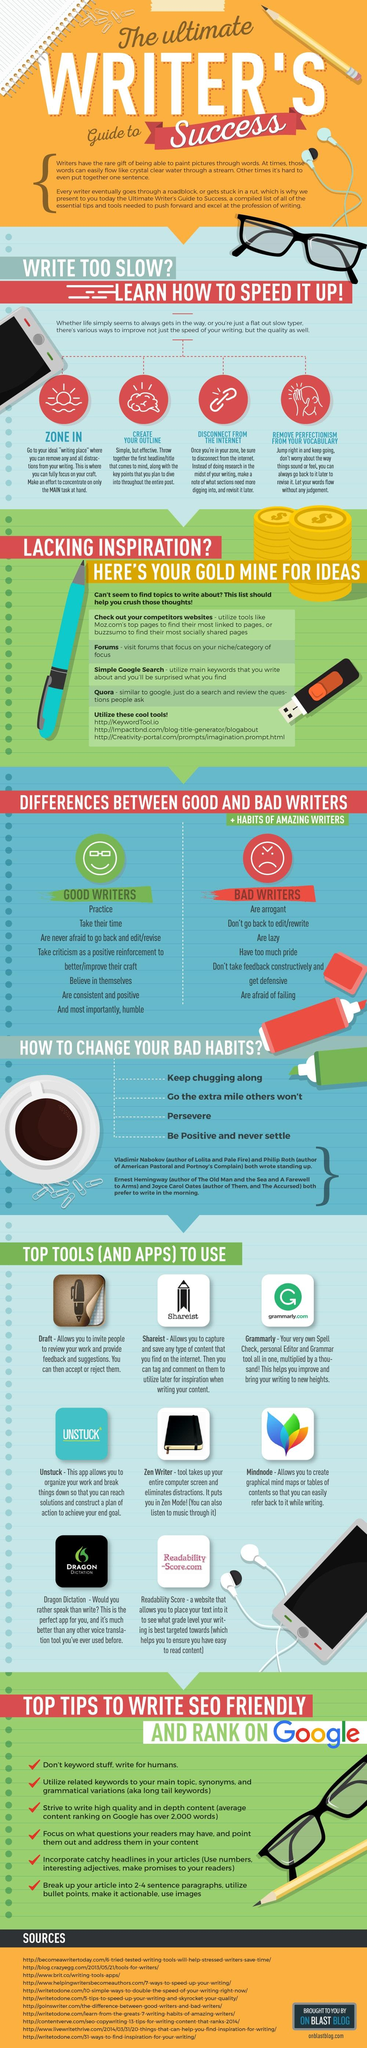Specify some key components in this picture. There are 11 sources listed at the bottom. Eight top tools and apps are listed. The infographic includes 14 paper clips. 